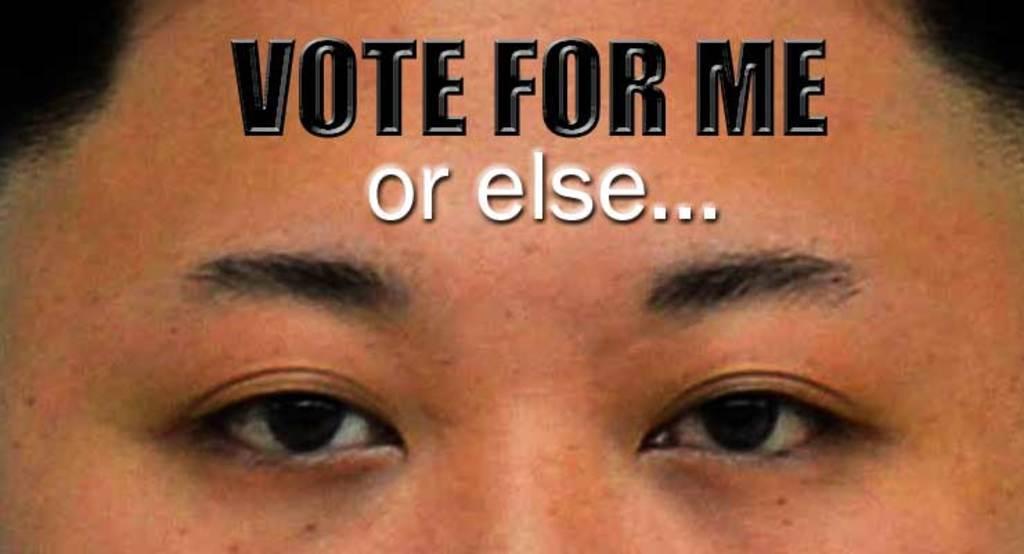Could you give a brief overview of what you see in this image? In this image we can see persons face and there is some text on the foreground of the image. 